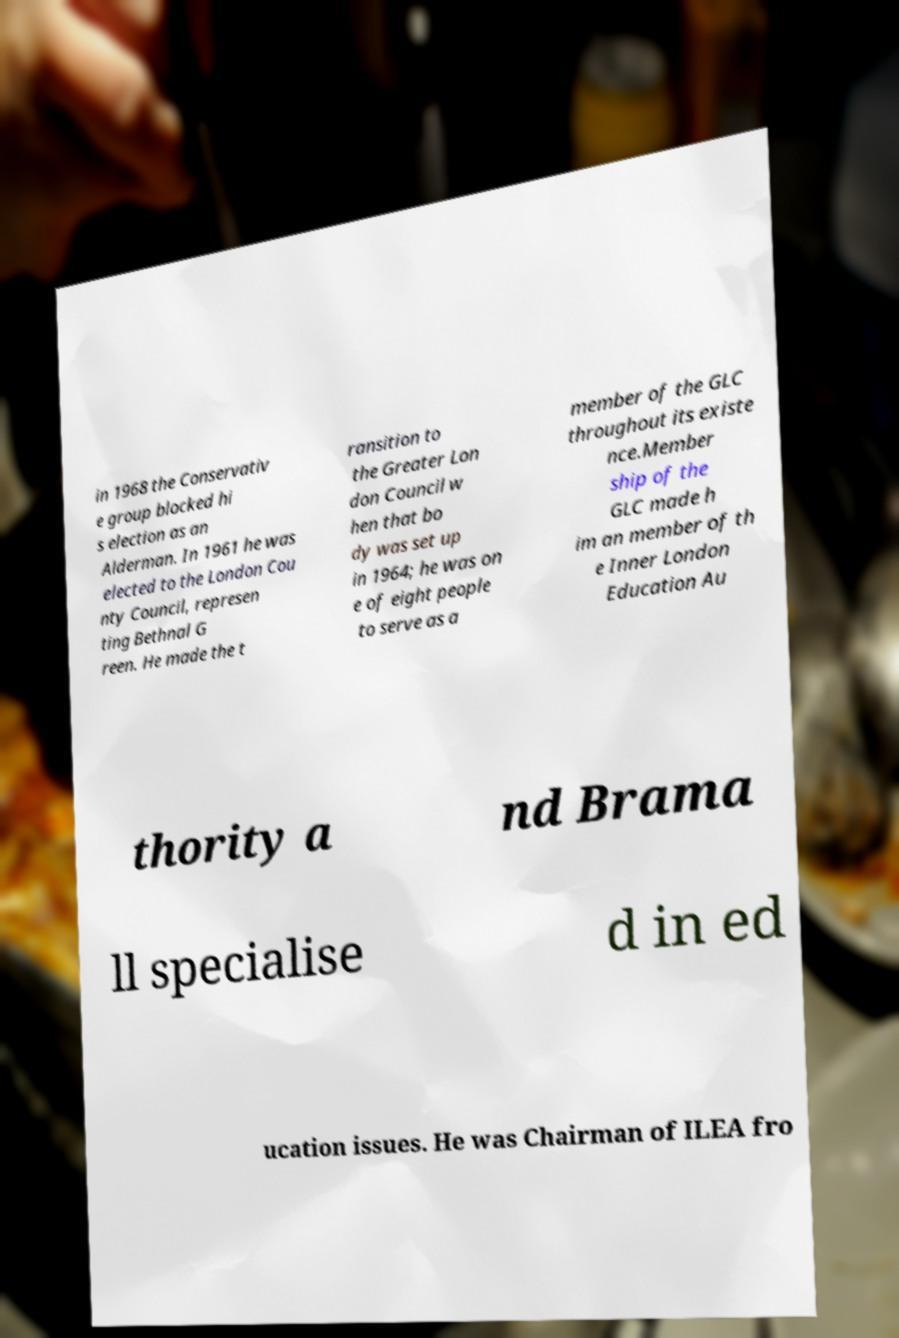Can you accurately transcribe the text from the provided image for me? in 1968 the Conservativ e group blocked hi s election as an Alderman. In 1961 he was elected to the London Cou nty Council, represen ting Bethnal G reen. He made the t ransition to the Greater Lon don Council w hen that bo dy was set up in 1964; he was on e of eight people to serve as a member of the GLC throughout its existe nce.Member ship of the GLC made h im an member of th e Inner London Education Au thority a nd Brama ll specialise d in ed ucation issues. He was Chairman of ILEA fro 